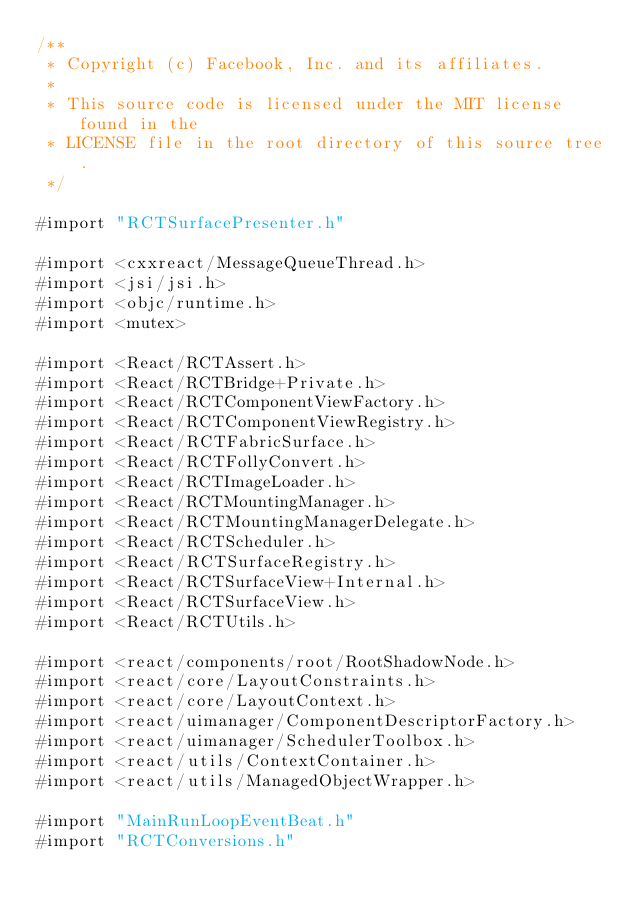<code> <loc_0><loc_0><loc_500><loc_500><_ObjectiveC_>/**
 * Copyright (c) Facebook, Inc. and its affiliates.
 *
 * This source code is licensed under the MIT license found in the
 * LICENSE file in the root directory of this source tree.
 */

#import "RCTSurfacePresenter.h"

#import <cxxreact/MessageQueueThread.h>
#import <jsi/jsi.h>
#import <objc/runtime.h>
#import <mutex>

#import <React/RCTAssert.h>
#import <React/RCTBridge+Private.h>
#import <React/RCTComponentViewFactory.h>
#import <React/RCTComponentViewRegistry.h>
#import <React/RCTFabricSurface.h>
#import <React/RCTFollyConvert.h>
#import <React/RCTImageLoader.h>
#import <React/RCTMountingManager.h>
#import <React/RCTMountingManagerDelegate.h>
#import <React/RCTScheduler.h>
#import <React/RCTSurfaceRegistry.h>
#import <React/RCTSurfaceView+Internal.h>
#import <React/RCTSurfaceView.h>
#import <React/RCTUtils.h>

#import <react/components/root/RootShadowNode.h>
#import <react/core/LayoutConstraints.h>
#import <react/core/LayoutContext.h>
#import <react/uimanager/ComponentDescriptorFactory.h>
#import <react/uimanager/SchedulerToolbox.h>
#import <react/utils/ContextContainer.h>
#import <react/utils/ManagedObjectWrapper.h>

#import "MainRunLoopEventBeat.h"
#import "RCTConversions.h"</code> 